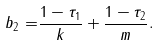<formula> <loc_0><loc_0><loc_500><loc_500>b _ { 2 } = & \frac { 1 - \tau _ { 1 } } { k } + \frac { 1 - \tau _ { 2 } } { m } .</formula> 